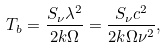<formula> <loc_0><loc_0><loc_500><loc_500>T _ { b } = \frac { S _ { \nu } \lambda ^ { 2 } } { 2 k \Omega } = \frac { S _ { \nu } c ^ { 2 } } { 2 k \Omega \nu ^ { 2 } } ,</formula> 